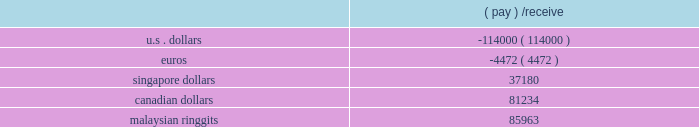Contracts as of december 31 , 2006 , which all mature in 2007 .
Forward contract notional amounts presented below are expressed in the stated currencies ( in thousands ) .
Forward currency contracts: .
A movement of 10% ( 10 % ) in the value of the u.s .
Dollar against foreign currencies would impact our expected net earnings by approximately $ 0.1 million .
Item 8 .
Financial statements and supplementary data the financial statements and supplementary data required by this item are included herein , commencing on page f-1 .
Item 9 .
Changes in and disagreements with accountants on accounting and financial disclosure item 9a .
Controls and procedures ( a ) evaluation of disclosure controls and procedures our management , with the participation of our chief executive officer and chief financial officer , evaluated the effectiveness of our disclosure controls and procedures as of the end of the period covered by this report .
Based on that evaluation , the chief executive officer and chief financial officer concluded that our disclosure controls and procedures as of the end of the period covered by this report are functioning effectively to provide reasonable assurance that the information required to be disclosed by us in reports filed under the securities exchange act of 1934 is ( i ) recorded , processed , summarized and reported within the time periods specified in the sec 2019s rules and forms and ( ii ) accumulated and communicated to our management , including the chief executive officer and chief financial officer , as appropriate to allow timely decisions regarding disclosure .
A controls system cannot provide absolute assurance , however , that the objectives of the controls system are met , and no evaluation of controls can provide absolute assurance that all control issues and instances of fraud , if any , within a company have been detected .
( b ) management 2019s report on internal control over financial reporting our management 2019s report on internal control over financial reporting is set forth on page f-2 of this annual report on form 10-k and is incorporated by reference herein .
( c ) change in internal control over financial reporting no change in our internal control over financial reporting occurred during our most recent fiscal quarter that has materially affected , or is reasonably likely to materially affect , our internal control over financial reporting .
Item 9b .
Other information .
If the u.s dollar would change by 5% ( 5 % ) against foreign currencies , what would the expected net earnings? 
Rationale: if a currency change of 10% would change the net earnings by $ 0.1 million . then dividing that in half to get a change in 5% . the answer would then be $ 0.05 million .
Computations: (0.1 / 2)
Answer: 0.05. 